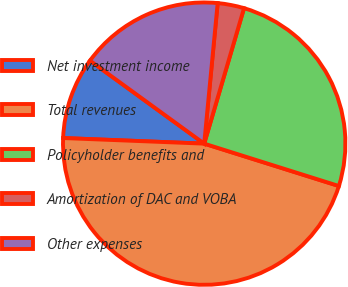<chart> <loc_0><loc_0><loc_500><loc_500><pie_chart><fcel>Net investment income<fcel>Total revenues<fcel>Policyholder benefits and<fcel>Amortization of DAC and VOBA<fcel>Other expenses<nl><fcel>9.37%<fcel>45.78%<fcel>25.3%<fcel>3.03%<fcel>16.52%<nl></chart> 